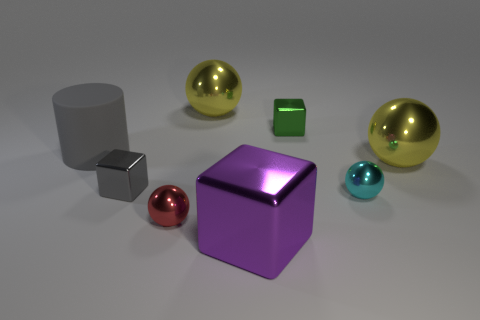Is the color of the cube that is on the left side of the large purple metal cube the same as the large cylinder?
Offer a terse response. Yes. How many small cubes are the same color as the large rubber thing?
Make the answer very short. 1. There is a thing that is the same color as the large cylinder; what material is it?
Ensure brevity in your answer.  Metal. Does the sphere behind the green metal thing have the same color as the large metal sphere to the right of the purple block?
Keep it short and to the point. Yes. What shape is the big shiny object in front of the yellow sphere on the right side of the large sphere to the left of the big metal cube?
Provide a short and direct response. Cube. There is a gray object that is made of the same material as the tiny green thing; what shape is it?
Offer a terse response. Cube. Is the material of the purple object the same as the tiny red ball?
Provide a short and direct response. Yes. Are there more red shiny objects than big yellow spheres?
Offer a very short reply. No. Does the cylinder have the same size as the green cube that is right of the big purple metal block?
Your answer should be very brief. No. What color is the large metallic ball right of the green block?
Ensure brevity in your answer.  Yellow. 